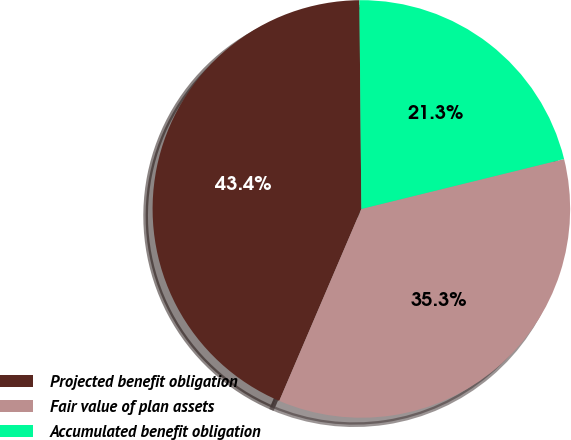Convert chart. <chart><loc_0><loc_0><loc_500><loc_500><pie_chart><fcel>Projected benefit obligation<fcel>Fair value of plan assets<fcel>Accumulated benefit obligation<nl><fcel>43.42%<fcel>35.28%<fcel>21.31%<nl></chart> 